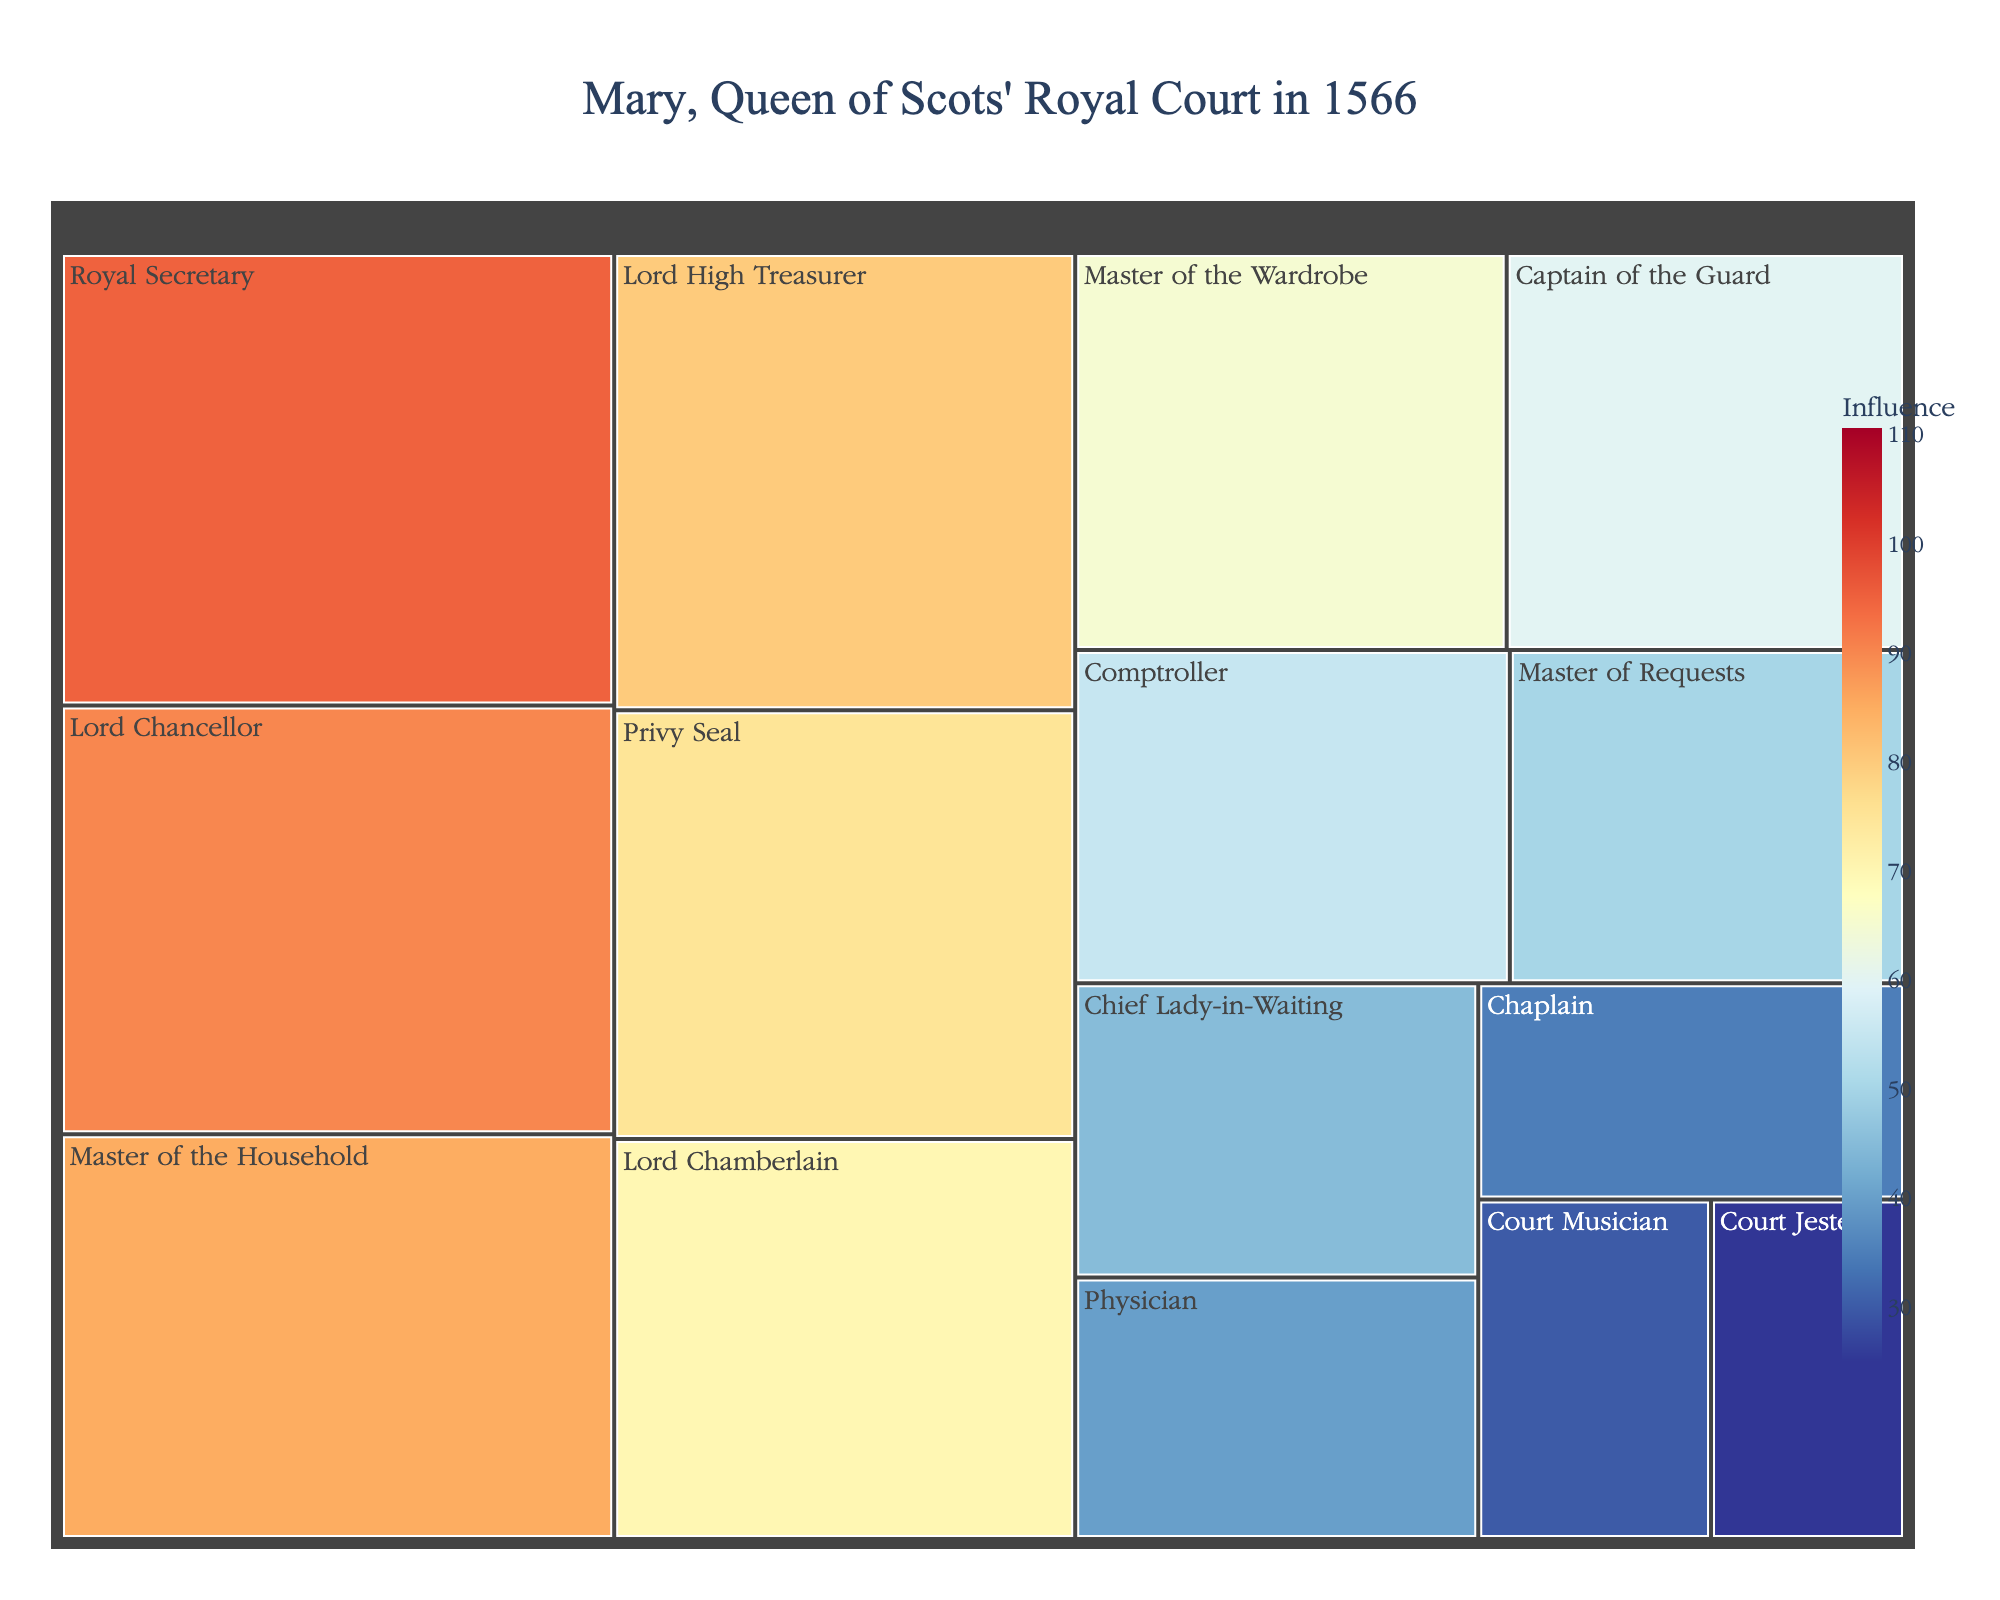How many roles are in Mary, Queen of Scots' royal court according to the treemap? You can see that each unique role has its own labeled section in the treemap. Simply count these labels.
Answer: 14 Which role has the highest influence in Mary, Queen of Scots' royal court? The role with the largest rectangle and the highest value for influence in the color scale will be the one with the highest influence.
Answer: Royal Secretary What is the total influence of the Master of the Household and the Lord Chancellor combined? Find the influence values for both roles, which are 85 for Master of the Household and 90 for Lord Chancellor. Add these values: 85 + 90.
Answer: 175 Who are the individuals holding roles with influence values between 50 and 70? Check the rectangles labeled with influence values in this range and identify the corresponding persons.
Answer: Mary Beaton, James Stewart of Cardonald, Sir John Bellenden of Auchnoul, John Wood Which role has the smallest influence in the treemap? The role with the smallest rectangle and the lowest influence value will be the one with the smallest influence.
Answer: Court Jester How does the influence of the Captain of the Guard compare to that of the Chief Lady-in-Waiting? Identify the influence values for both roles, which are 60 for Captain of the Guard and 45 for Chief Lady-in-Waiting. Compare the two values: 60 is greater than 45.
Answer: Greater What is the average influence of roles in the royal court? Add up all the influence values provided in the data and divide by the total number of roles (14). Sum: 95+90+85+80+75+70+65+60+55+50+45+40+35+30+25 = 900. Average: 900 / 14.
Answer: 64.29 Which roles are held by individuals named "Stewart"? Identify roles for all persons with the last name "Stewart."
Answer: Lord Chancellor, Captain of the Guard, Lord High Treasurer What is the difference in influence between the highest and lowest roles? Subtract the influence value of the smallest role (Court Jester: 25) from the influence value of the highest role (Royal Secretary: 95).
Answer: 70 Is the influence of the Privy Seal higher or lower than the average influence of the court? Find the influence value of the Privy Seal (75) and compare it to the calculated average influence (64.29). Since 75 > 64.29, it is higher.
Answer: Higher 